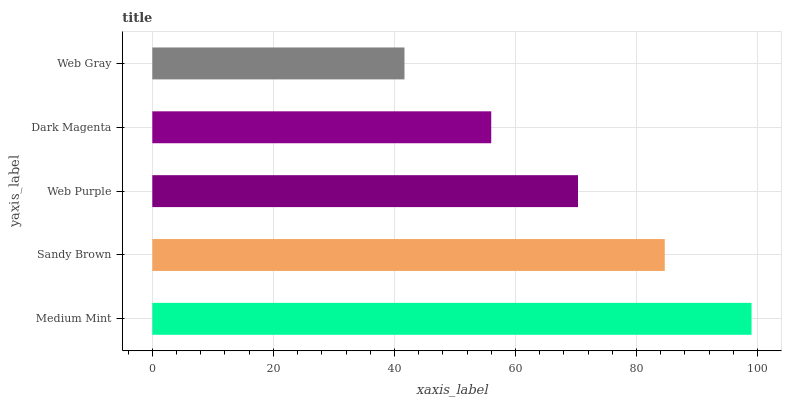Is Web Gray the minimum?
Answer yes or no. Yes. Is Medium Mint the maximum?
Answer yes or no. Yes. Is Sandy Brown the minimum?
Answer yes or no. No. Is Sandy Brown the maximum?
Answer yes or no. No. Is Medium Mint greater than Sandy Brown?
Answer yes or no. Yes. Is Sandy Brown less than Medium Mint?
Answer yes or no. Yes. Is Sandy Brown greater than Medium Mint?
Answer yes or no. No. Is Medium Mint less than Sandy Brown?
Answer yes or no. No. Is Web Purple the high median?
Answer yes or no. Yes. Is Web Purple the low median?
Answer yes or no. Yes. Is Dark Magenta the high median?
Answer yes or no. No. Is Medium Mint the low median?
Answer yes or no. No. 